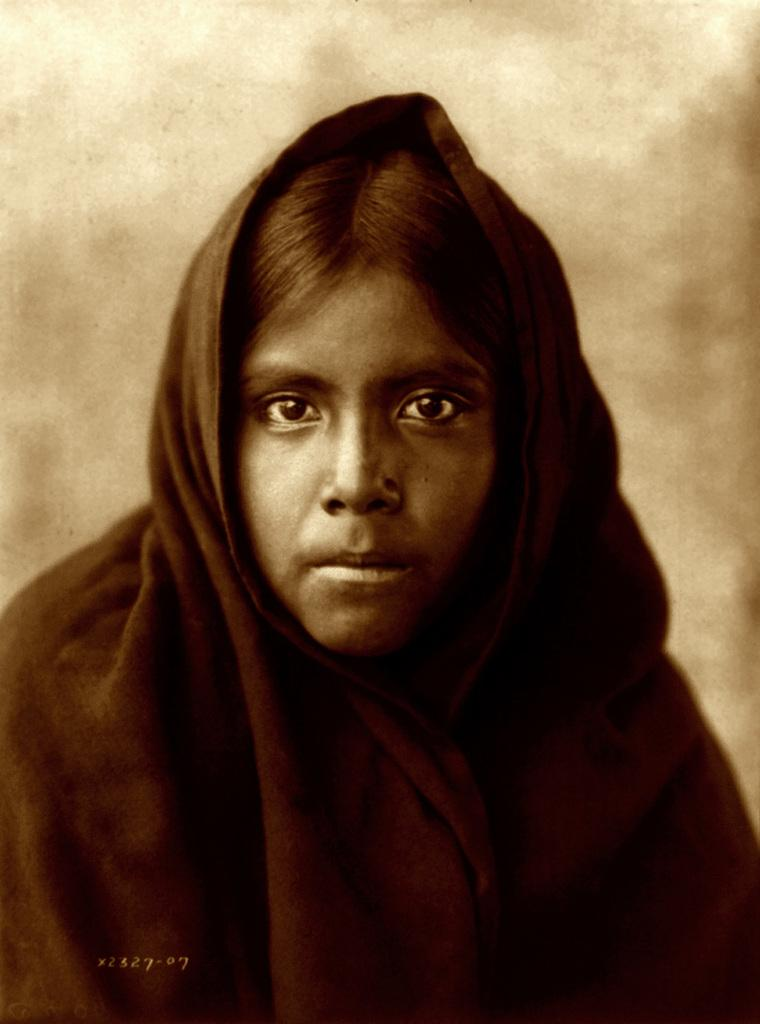What can be seen in the image? There is a person in the image. What is the person holding? The person is holding a cloth. Can you describe the background of the image? The background of the image is blurred. Is there any additional information or markings on the image? Yes, there is a watermark at the bottom of the image. How many men are wearing coats in the image? There are no men or coats present in the image. What type of recess is visible in the image? There is no recess visible in the image. 